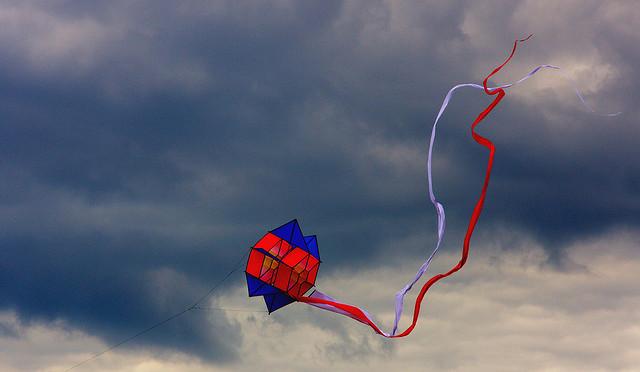What is flying in the sky?
Short answer required. Kite. What is the weather like?
Concise answer only. Windy. What colors are the kite's tails?
Answer briefly. Red and purple. 